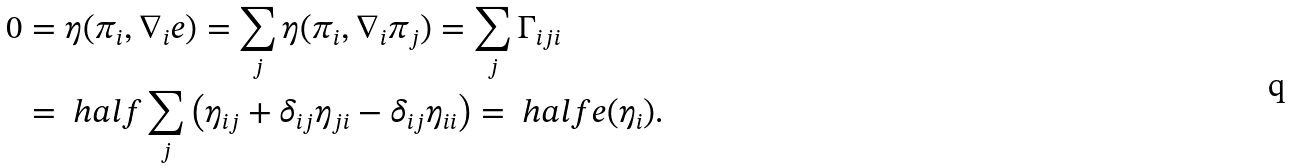Convert formula to latex. <formula><loc_0><loc_0><loc_500><loc_500>0 & = \eta ( \pi _ { i } , \nabla _ { i } e ) = \sum _ { j } \eta ( \pi _ { i } , \nabla _ { i } \pi _ { j } ) = \sum _ { j } \Gamma _ { i j i } \\ & = \ h a l f \sum _ { j } \left ( \eta _ { i j } + \delta _ { i j } \eta _ { j i } - \delta _ { i j } \eta _ { i i } \right ) = \ h a l f e ( \eta _ { i } ) .</formula> 